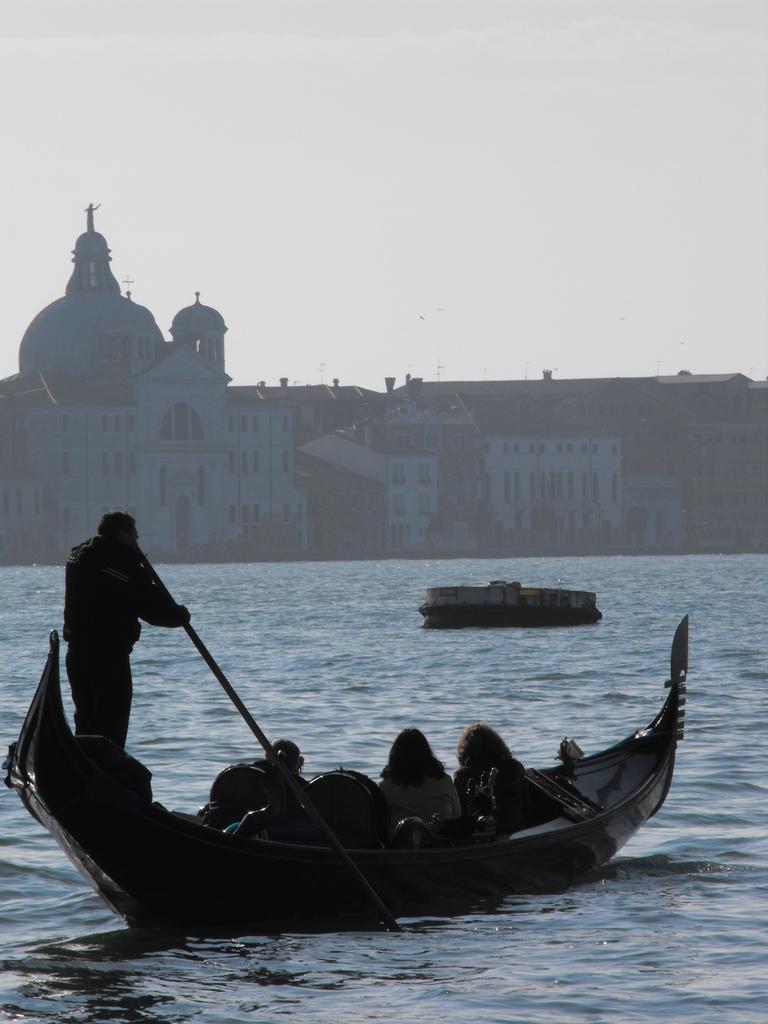Describe this image in one or two sentences. In the foreground of the image we can see water body and a boat in which some persons are sitting. In the middle of the image we can see a building. On the top of the image we can see the sky. 